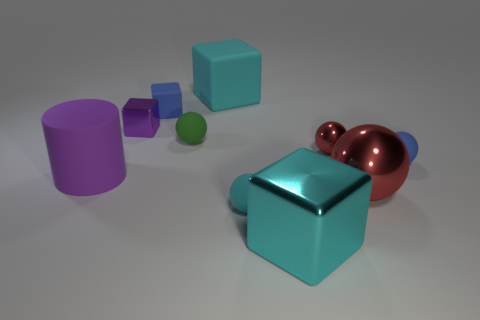The green rubber thing that is to the left of the red shiny object that is behind the purple cylinder is what shape?
Offer a very short reply. Sphere. The tiny blue object to the right of the blue thing that is on the left side of the big object behind the purple rubber object is what shape?
Provide a short and direct response. Sphere. What number of small rubber objects have the same shape as the tiny purple shiny object?
Make the answer very short. 1. There is a small blue object to the right of the cyan metal block; what number of cyan cubes are behind it?
Offer a very short reply. 1. How many rubber objects are either tiny yellow objects or big cubes?
Keep it short and to the point. 1. Is there another block made of the same material as the tiny purple block?
Keep it short and to the point. Yes. What number of things are cubes that are on the left side of the large shiny cube or blue objects that are to the right of the large cyan rubber thing?
Keep it short and to the point. 4. There is a big object that is behind the green rubber object; is it the same color as the large metallic sphere?
Provide a short and direct response. No. What number of other things are there of the same color as the big metal cube?
Keep it short and to the point. 2. What material is the blue cube?
Your response must be concise. Rubber. 